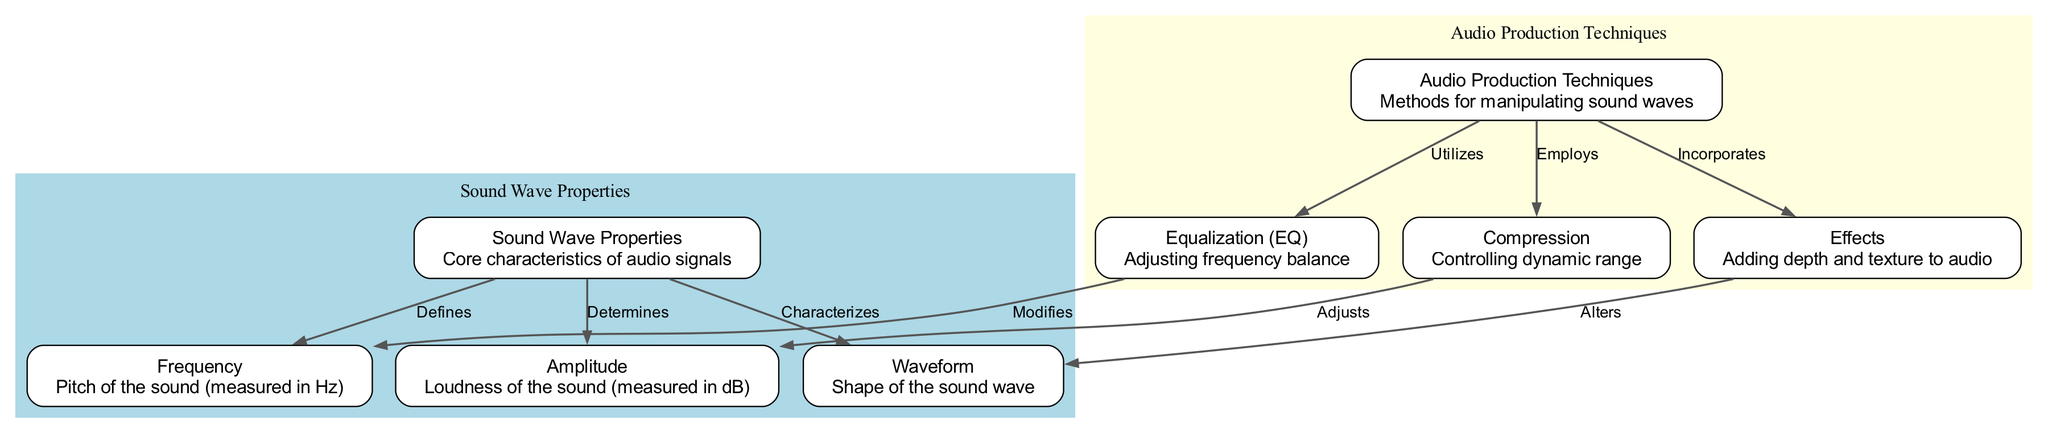What is the main topic of the diagram? The diagram focuses on sound wave properties and audio production techniques, as indicated by the title and organization of nodes into two clusters.
Answer: Sound Wave Properties and Audio Production Techniques How many nodes are there in total? By counting the total number of nodes listed in the data, there are 8 nodes.
Answer: 8 What role does frequency play in sound waves? Frequency is defined as the pitch of the sound measured in Hz, according to the connection seen between the "Sound Wave Properties" node and the "Frequency" node.
Answer: Pitch of the sound (measured in Hz) Which audio production technique modifies frequency? The technique identified as "Equalization (EQ)" is specifically mentioned to modify frequency, according to the edge linking "Equalization (EQ)" to "Frequency."
Answer: Equalization (EQ) What property does amplitude determine? Amplitude determines the loudness of the sound, based on the relationship indicated in the diagram between the "Sound Wave Properties" and "Amplitude."
Answer: Loudness of the sound (measured in dB) Which technique is used to control dynamic range? The diagram indicates that "Compression" is the technique used to control dynamic range, shown by the edge from the "Audio Production Techniques" node to "Compression."
Answer: Compression How does "Effects" alter sound in audio production? "Effects" incorporate additional depth and texture to audio, as identified from the connection in the diagram. Thus, it adds complexity to the audio signal.
Answer: Adding depth and texture to audio What is the relationship between "Waveform" and sound waves? The relationship shows that "Waveform" characterizes the shape of the sound wave, as depicted by the edge from "Sound Wave Properties" to "Waveform."
Answer: Shape of the sound wave Which audio production technique utilizes equalization? "Audio Production Techniques" utilizes "Equalization (EQ)," as shown by the directed edge in the diagram connecting these two nodes.
Answer: Equalization (EQ) 